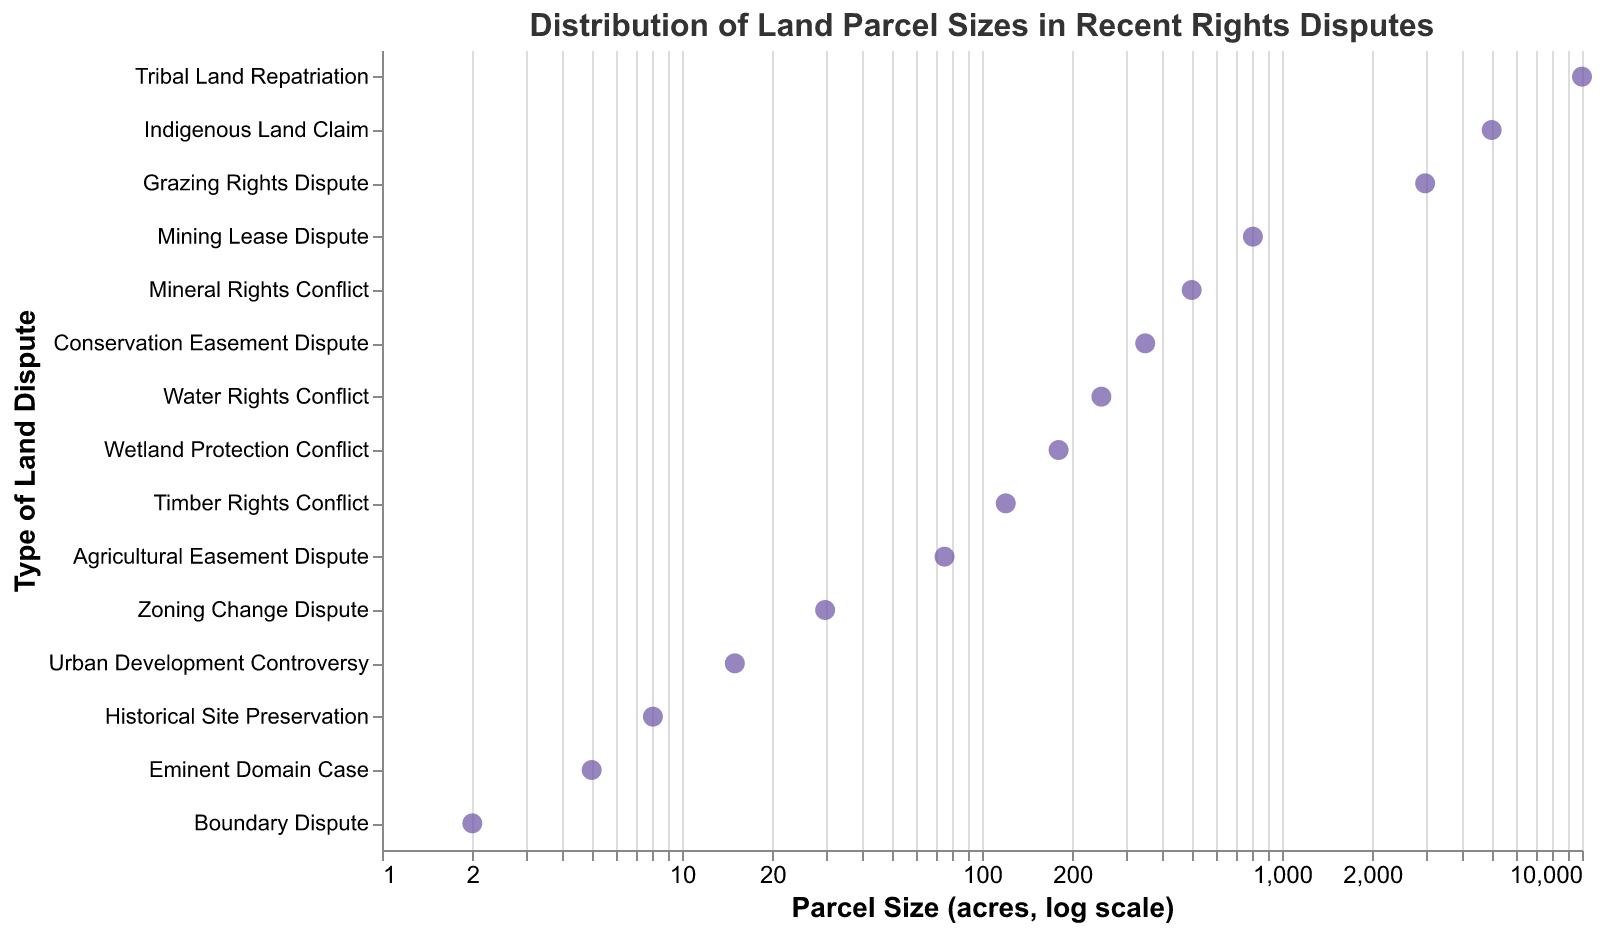What is the title of the figure? The title is usually located at the top of the figure, providing an overview of the content and focus of the plot.
Answer: Distribution of Land Parcel Sizes in Recent Rights Disputes How many types of land disputes are presented in the figure? Count the distinct points along the y-axis, each representing a different type of dispute.
Answer: 15 Which land dispute involves the largest parcel size? Identify the point furthest to the right on the x-axis, indicating the largest parcel size. The 'tooltip' or labels can help validate the type of dispute.
Answer: Tribal Land Repatriation What is the parcel size of the Eminent Domain Case dispute? Locate the Eminent Domain Case on the y-axis and note its corresponding point on the x-axis. The tooltip or labels will show the parcel size.
Answer: 5 acres How does the parcel size for Indigenous Land Claim compare to that of Water Rights Conflict? Find and compare the x-axis positions for both disputes. Indigenous Land Claim is further to the right (5000 acres) than Water Rights Conflict (250 acres).
Answer: Indigenous Land Claim is larger What is the median parcel size of the listed land disputes? Arrange the parcel sizes in ascending order and pick the middle value. For 15 values, the 8th value in the sorted list represents the median.
Answer: 120 acres Which land disputes fall within the parcel size range of 100 to 500 acres? Identify points on the x-axis within the range 100-500 and note the corresponding y-axis labels.
Answer: Timber Rights Conflict, Mineral Rights Conflict, Conservation Easement Dispute What is the range of parcel sizes involved in the disputes? Calculate the difference between the largest (Tribal Land Repatriation: 10000 acres) and smallest (Boundary Dispute: 2 acres).
Answer: 9998 acres What is the average parcel size of Agricultural Easement Dispute, Urban Development Controversy, and Historical Site Preservation disputes? Add the parcel sizes for each dispute (75 + 15 + 8), then divide by the number of disputes (3).
Answer: 32.67 acres How many disputes involve parcel sizes less than 100 acres? Count the points on the x-axis to the left of the 100-acre mark. These include Agricultural Easement Dispute, Urban Development Controversy, Eminent Domain Case, Boundary Dispute, Historical Site Preservation, and Zoning Change Dispute.
Answer: 6 